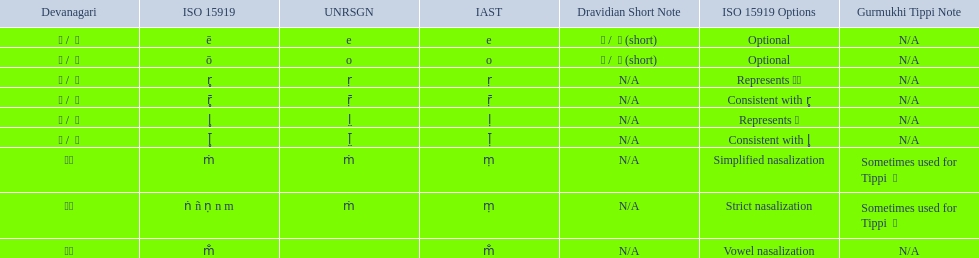How many total options are there about anusvara? 2. 